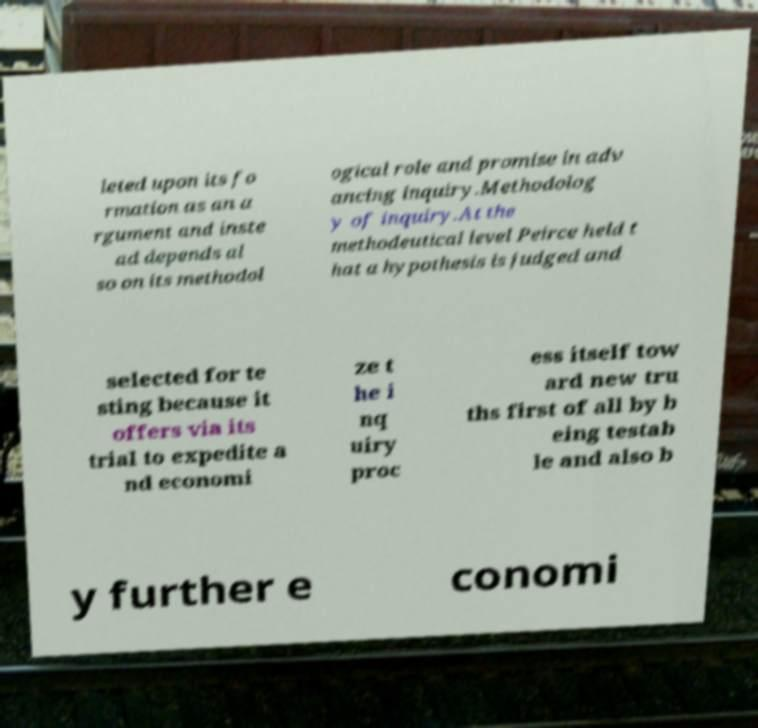Please read and relay the text visible in this image. What does it say? leted upon its fo rmation as an a rgument and inste ad depends al so on its methodol ogical role and promise in adv ancing inquiry.Methodolog y of inquiry.At the methodeutical level Peirce held t hat a hypothesis is judged and selected for te sting because it offers via its trial to expedite a nd economi ze t he i nq uiry proc ess itself tow ard new tru ths first of all by b eing testab le and also b y further e conomi 